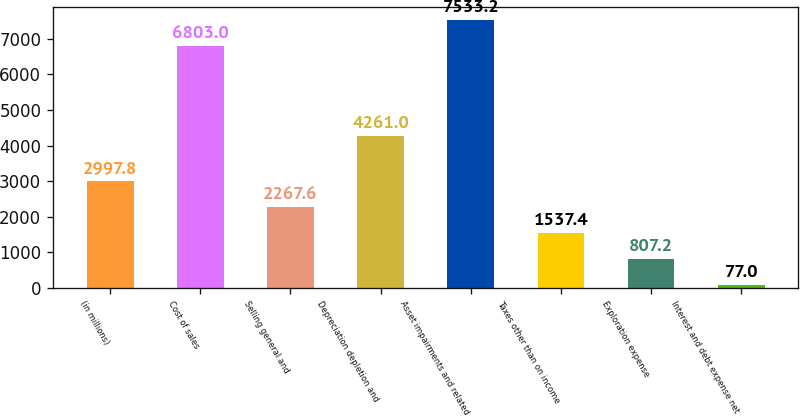Convert chart to OTSL. <chart><loc_0><loc_0><loc_500><loc_500><bar_chart><fcel>(in millions)<fcel>Cost of sales<fcel>Selling general and<fcel>Depreciation depletion and<fcel>Asset impairments and related<fcel>Taxes other than on income<fcel>Exploration expense<fcel>Interest and debt expense net<nl><fcel>2997.8<fcel>6803<fcel>2267.6<fcel>4261<fcel>7533.2<fcel>1537.4<fcel>807.2<fcel>77<nl></chart> 